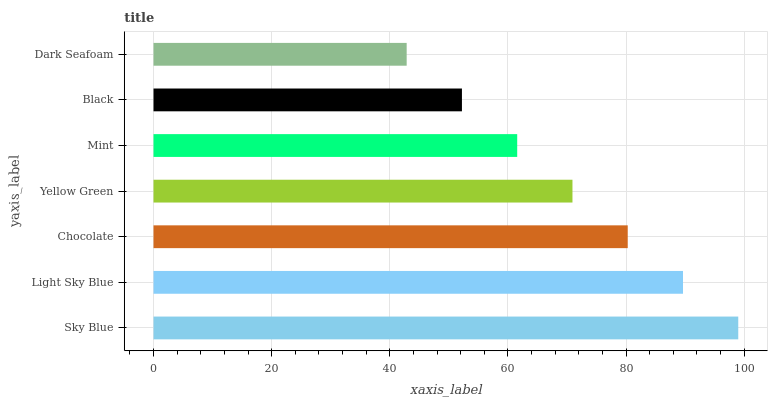Is Dark Seafoam the minimum?
Answer yes or no. Yes. Is Sky Blue the maximum?
Answer yes or no. Yes. Is Light Sky Blue the minimum?
Answer yes or no. No. Is Light Sky Blue the maximum?
Answer yes or no. No. Is Sky Blue greater than Light Sky Blue?
Answer yes or no. Yes. Is Light Sky Blue less than Sky Blue?
Answer yes or no. Yes. Is Light Sky Blue greater than Sky Blue?
Answer yes or no. No. Is Sky Blue less than Light Sky Blue?
Answer yes or no. No. Is Yellow Green the high median?
Answer yes or no. Yes. Is Yellow Green the low median?
Answer yes or no. Yes. Is Black the high median?
Answer yes or no. No. Is Dark Seafoam the low median?
Answer yes or no. No. 